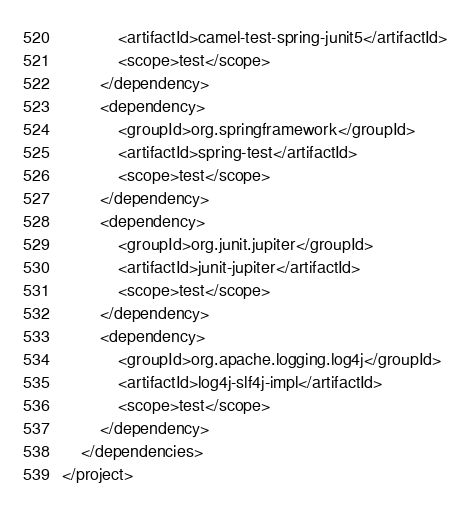Convert code to text. <code><loc_0><loc_0><loc_500><loc_500><_XML_>            <artifactId>camel-test-spring-junit5</artifactId>
            <scope>test</scope>
        </dependency>
        <dependency>
            <groupId>org.springframework</groupId>
            <artifactId>spring-test</artifactId>
            <scope>test</scope>
        </dependency>
        <dependency>
            <groupId>org.junit.jupiter</groupId>
            <artifactId>junit-jupiter</artifactId>
            <scope>test</scope>
        </dependency>
        <dependency>
            <groupId>org.apache.logging.log4j</groupId>
            <artifactId>log4j-slf4j-impl</artifactId>
            <scope>test</scope>
        </dependency>
    </dependencies>
</project>
</code> 